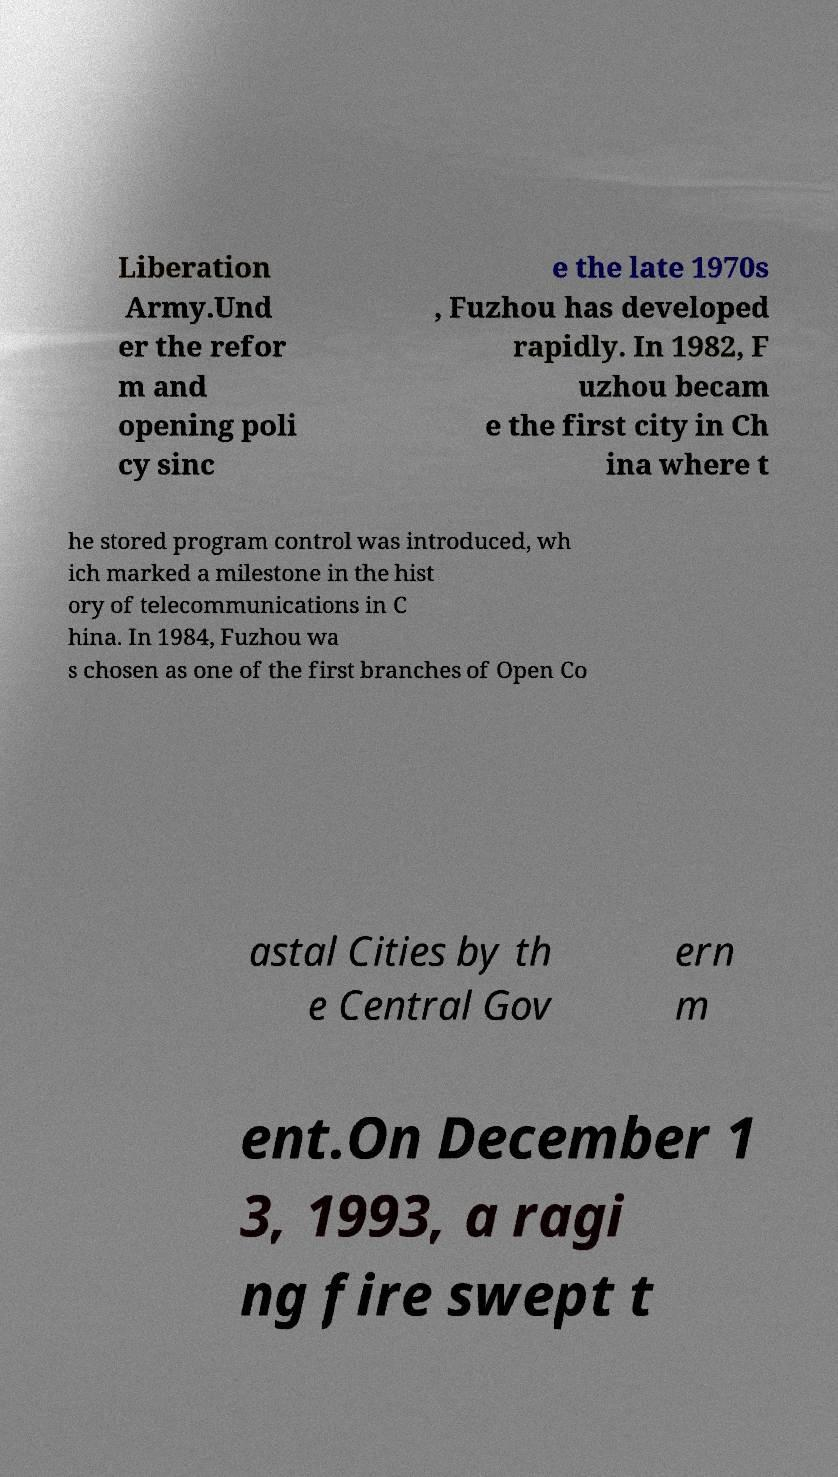What messages or text are displayed in this image? I need them in a readable, typed format. Liberation Army.Und er the refor m and opening poli cy sinc e the late 1970s , Fuzhou has developed rapidly. In 1982, F uzhou becam e the first city in Ch ina where t he stored program control was introduced, wh ich marked a milestone in the hist ory of telecommunications in C hina. In 1984, Fuzhou wa s chosen as one of the first branches of Open Co astal Cities by th e Central Gov ern m ent.On December 1 3, 1993, a ragi ng fire swept t 